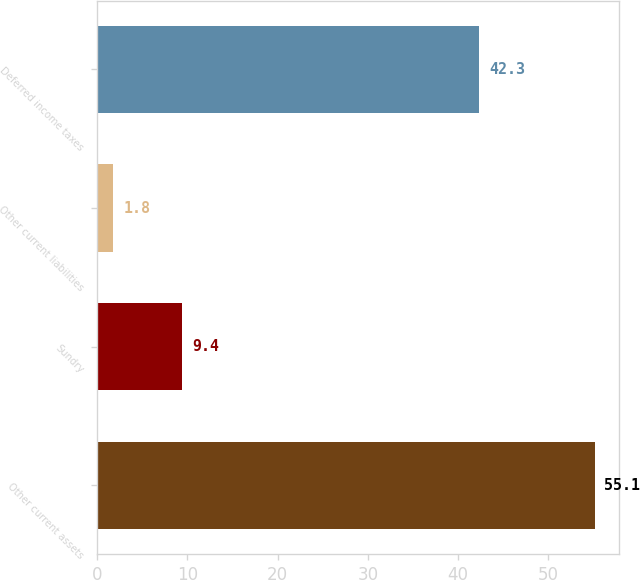Convert chart to OTSL. <chart><loc_0><loc_0><loc_500><loc_500><bar_chart><fcel>Other current assets<fcel>Sundry<fcel>Other current liabilities<fcel>Deferred income taxes<nl><fcel>55.1<fcel>9.4<fcel>1.8<fcel>42.3<nl></chart> 